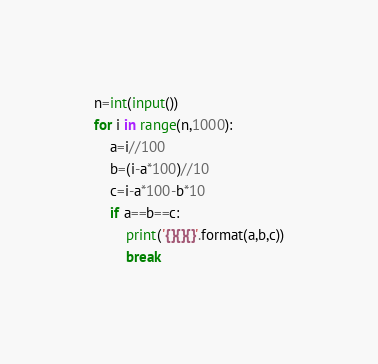<code> <loc_0><loc_0><loc_500><loc_500><_Python_>n=int(input())
for i in range(n,1000):
    a=i//100
    b=(i-a*100)//10
    c=i-a*100-b*10
    if a==b==c:
        print('{}{}{}'.format(a,b,c))
        break
</code> 